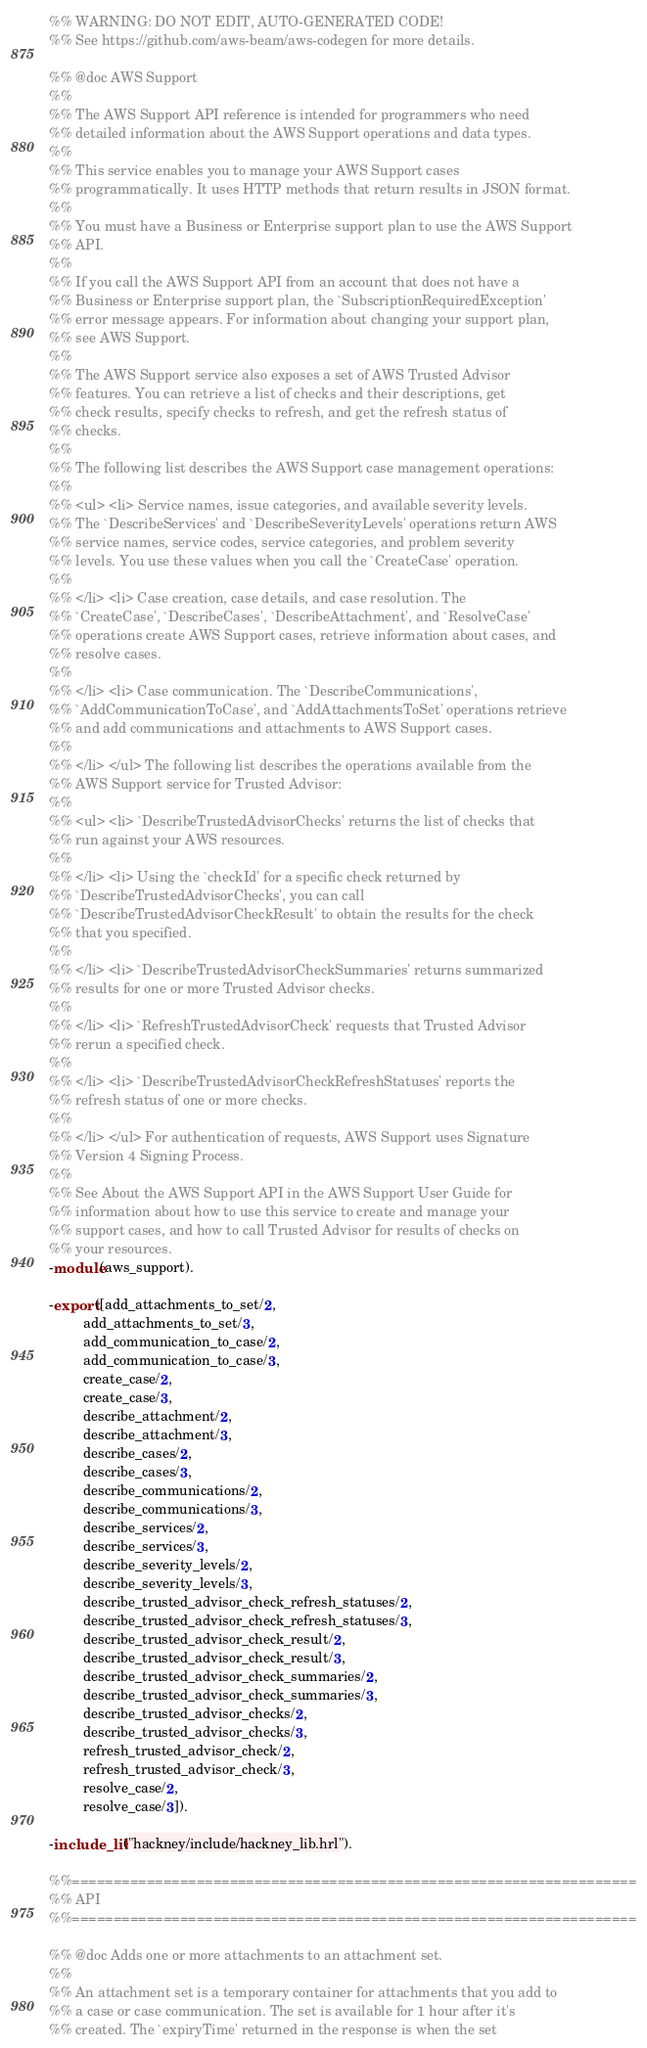<code> <loc_0><loc_0><loc_500><loc_500><_Erlang_>%% WARNING: DO NOT EDIT, AUTO-GENERATED CODE!
%% See https://github.com/aws-beam/aws-codegen for more details.

%% @doc AWS Support
%%
%% The AWS Support API reference is intended for programmers who need
%% detailed information about the AWS Support operations and data types.
%%
%% This service enables you to manage your AWS Support cases
%% programmatically. It uses HTTP methods that return results in JSON format.
%%
%% You must have a Business or Enterprise support plan to use the AWS Support
%% API.
%%
%% If you call the AWS Support API from an account that does not have a
%% Business or Enterprise support plan, the `SubscriptionRequiredException'
%% error message appears. For information about changing your support plan,
%% see AWS Support.
%%
%% The AWS Support service also exposes a set of AWS Trusted Advisor
%% features. You can retrieve a list of checks and their descriptions, get
%% check results, specify checks to refresh, and get the refresh status of
%% checks.
%%
%% The following list describes the AWS Support case management operations:
%%
%% <ul> <li> Service names, issue categories, and available severity levels.
%% The `DescribeServices' and `DescribeSeverityLevels' operations return AWS
%% service names, service codes, service categories, and problem severity
%% levels. You use these values when you call the `CreateCase' operation.
%%
%% </li> <li> Case creation, case details, and case resolution. The
%% `CreateCase', `DescribeCases', `DescribeAttachment', and `ResolveCase'
%% operations create AWS Support cases, retrieve information about cases, and
%% resolve cases.
%%
%% </li> <li> Case communication. The `DescribeCommunications',
%% `AddCommunicationToCase', and `AddAttachmentsToSet' operations retrieve
%% and add communications and attachments to AWS Support cases.
%%
%% </li> </ul> The following list describes the operations available from the
%% AWS Support service for Trusted Advisor:
%%
%% <ul> <li> `DescribeTrustedAdvisorChecks' returns the list of checks that
%% run against your AWS resources.
%%
%% </li> <li> Using the `checkId' for a specific check returned by
%% `DescribeTrustedAdvisorChecks', you can call
%% `DescribeTrustedAdvisorCheckResult' to obtain the results for the check
%% that you specified.
%%
%% </li> <li> `DescribeTrustedAdvisorCheckSummaries' returns summarized
%% results for one or more Trusted Advisor checks.
%%
%% </li> <li> `RefreshTrustedAdvisorCheck' requests that Trusted Advisor
%% rerun a specified check.
%%
%% </li> <li> `DescribeTrustedAdvisorCheckRefreshStatuses' reports the
%% refresh status of one or more checks.
%%
%% </li> </ul> For authentication of requests, AWS Support uses Signature
%% Version 4 Signing Process.
%%
%% See About the AWS Support API in the AWS Support User Guide for
%% information about how to use this service to create and manage your
%% support cases, and how to call Trusted Advisor for results of checks on
%% your resources.
-module(aws_support).

-export([add_attachments_to_set/2,
         add_attachments_to_set/3,
         add_communication_to_case/2,
         add_communication_to_case/3,
         create_case/2,
         create_case/3,
         describe_attachment/2,
         describe_attachment/3,
         describe_cases/2,
         describe_cases/3,
         describe_communications/2,
         describe_communications/3,
         describe_services/2,
         describe_services/3,
         describe_severity_levels/2,
         describe_severity_levels/3,
         describe_trusted_advisor_check_refresh_statuses/2,
         describe_trusted_advisor_check_refresh_statuses/3,
         describe_trusted_advisor_check_result/2,
         describe_trusted_advisor_check_result/3,
         describe_trusted_advisor_check_summaries/2,
         describe_trusted_advisor_check_summaries/3,
         describe_trusted_advisor_checks/2,
         describe_trusted_advisor_checks/3,
         refresh_trusted_advisor_check/2,
         refresh_trusted_advisor_check/3,
         resolve_case/2,
         resolve_case/3]).

-include_lib("hackney/include/hackney_lib.hrl").

%%====================================================================
%% API
%%====================================================================

%% @doc Adds one or more attachments to an attachment set.
%%
%% An attachment set is a temporary container for attachments that you add to
%% a case or case communication. The set is available for 1 hour after it's
%% created. The `expiryTime' returned in the response is when the set</code> 